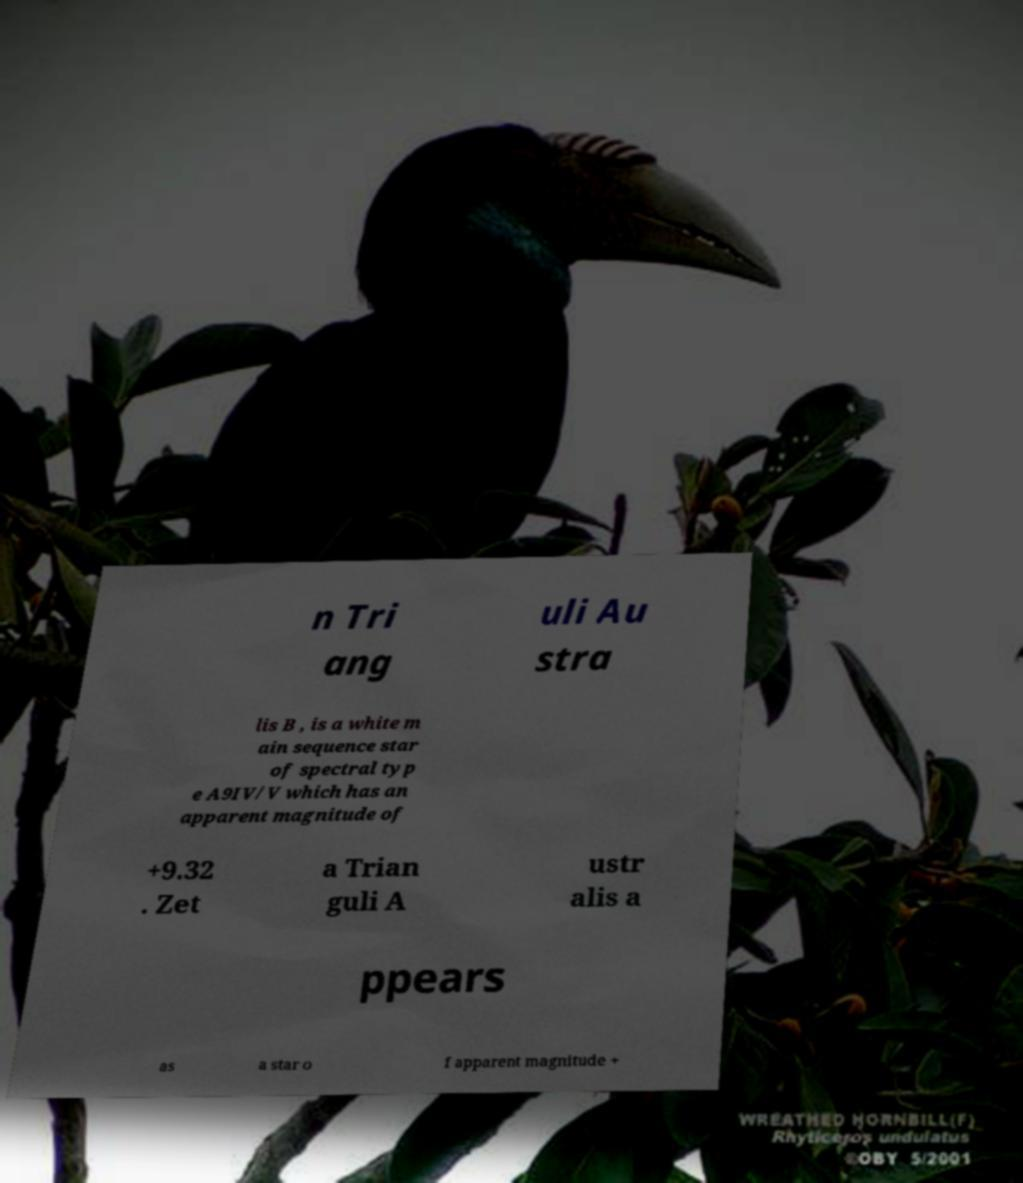I need the written content from this picture converted into text. Can you do that? n Tri ang uli Au stra lis B , is a white m ain sequence star of spectral typ e A9IV/V which has an apparent magnitude of +9.32 . Zet a Trian guli A ustr alis a ppears as a star o f apparent magnitude + 